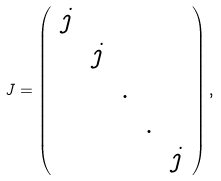<formula> <loc_0><loc_0><loc_500><loc_500>J = \left ( \begin{array} { c c c c c } j & & & & \\ & j & & & \\ & & . & & \\ & & & . & \\ & & & & j \end{array} \right ) ,</formula> 